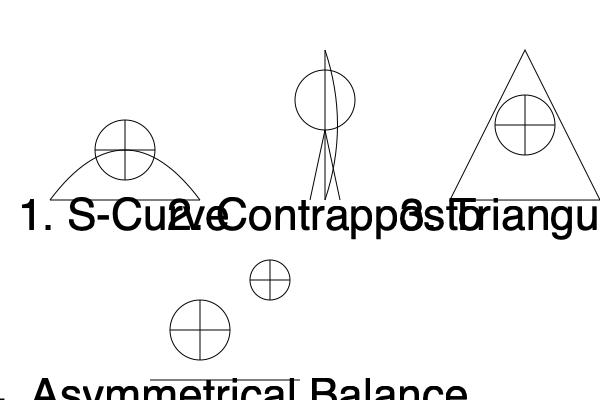In Marc Hom's fashion photography, models often employ various posing techniques to create visually striking images. Analyze the stick figure illustrations above, which represent common posing techniques used in Hom's work. Which technique is most effective for creating a sense of movement and fluidity in a static photograph, and why? To answer this question, let's analyze each posing technique illustrated:

1. S-Curve: This technique involves creating a subtle S-shape with the model's body. It adds grace and elegance to the pose, creating a flowing line that guides the viewer's eye through the image.

2. Contrapposto: This classical pose involves shifting the model's weight onto one leg, causing the hips and shoulders to tilt in opposite directions. It creates a dynamic, relaxed appearance and breaks the symmetry of the body.

3. Triangular Composition: This technique arranges the model's body or multiple models to form a triangle shape. It provides stability and balance to the composition but doesn't necessarily imply movement.

4. Asymmetrical Balance: This pose distributes visual elements unevenly across the frame, creating tension and interest. While it can be dynamic, it doesn't inherently suggest fluid movement.

Among these techniques, the S-Curve is most effective for creating a sense of movement and fluidity in a static photograph. Here's why:

1. Continuous Flow: The S-Curve creates a continuous, unbroken line through the body, which naturally leads the viewer's eye through the image. This flow mimics movement, even in a still image.

2. Dynamic Tension: The curve introduces a subtle tension between different parts of the body, suggesting potential energy and implied motion.

3. Versatility: The S-Curve can be incorporated into various poses and compositions, making it adaptable to different styling and photography concepts.

4. Natural Grace: This pose often appears more natural and less rigid than some other techniques, enhancing the sense of fluidity.

5. Historical Significance: The S-Curve has been used in art for centuries to convey grace and movement, particularly in sculpture and painting, making it a timeless technique in fashion photography as well.

While all these techniques have their place in fashion photography, the S-Curve stands out for its ability to infuse a static image with a sense of motion and fluidity, aligning well with Marc Hom's dynamic and elegant photographic style.
Answer: S-Curve 